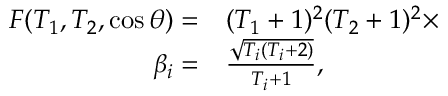Convert formula to latex. <formula><loc_0><loc_0><loc_500><loc_500>\begin{array} { r l } { F ( T _ { 1 } , T _ { 2 } , \cos { \theta } ) = } & ( T _ { 1 } + 1 ) ^ { 2 } ( T _ { 2 } + 1 ) ^ { 2 } \times } \\ { \beta _ { i } = } & \frac { \sqrt { T _ { i } ( T _ { i } + 2 ) } } { T _ { i } + 1 } , } \end{array}</formula> 